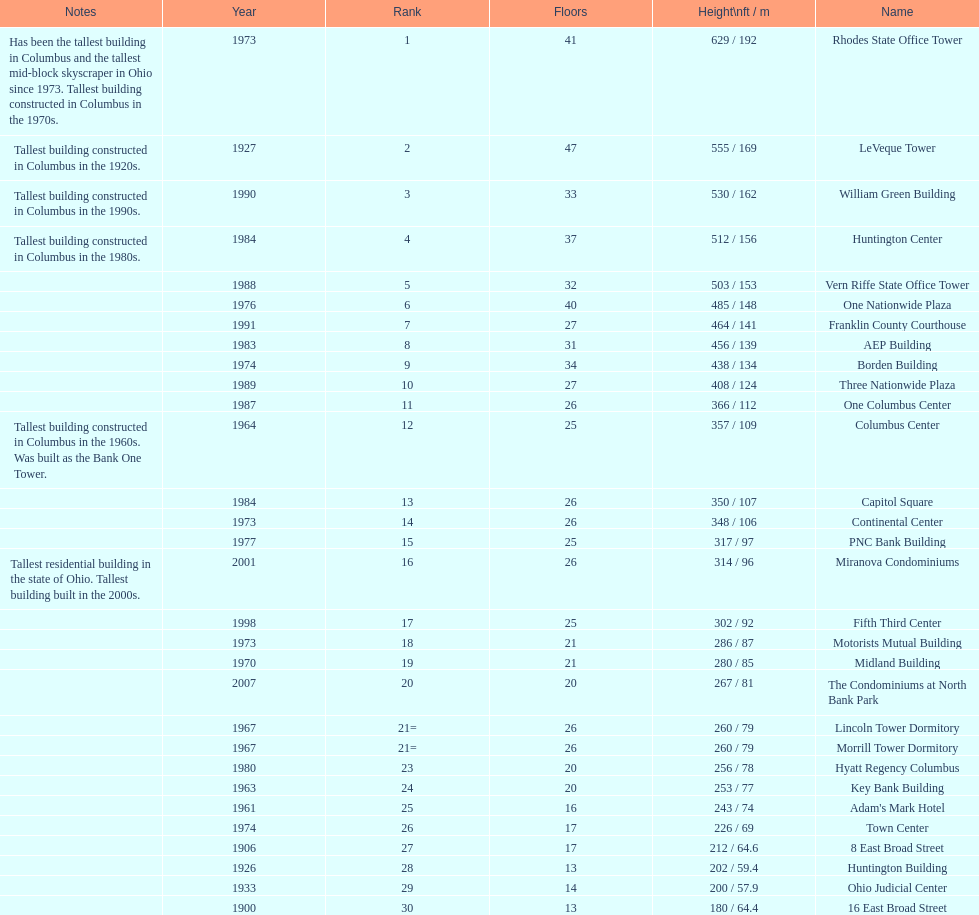What is the tallest building in columbus? Rhodes State Office Tower. 